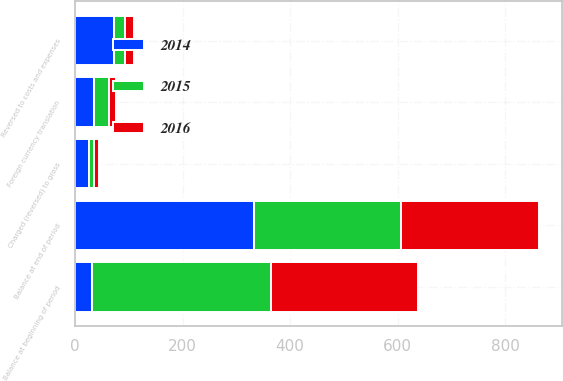Convert chart. <chart><loc_0><loc_0><loc_500><loc_500><stacked_bar_chart><ecel><fcel>Balance at beginning of period<fcel>Reversed to costs and expenses<fcel>Charged (reversed) to gross<fcel>Foreign currency translation<fcel>Balance at end of period<nl><fcel>2016<fcel>275.1<fcel>15.4<fcel>9.5<fcel>13.6<fcel>255.6<nl><fcel>2015<fcel>332.2<fcel>20.8<fcel>9.2<fcel>27.1<fcel>275.1<nl><fcel>2014<fcel>31.5<fcel>72.8<fcel>26.4<fcel>35.9<fcel>332.2<nl></chart> 